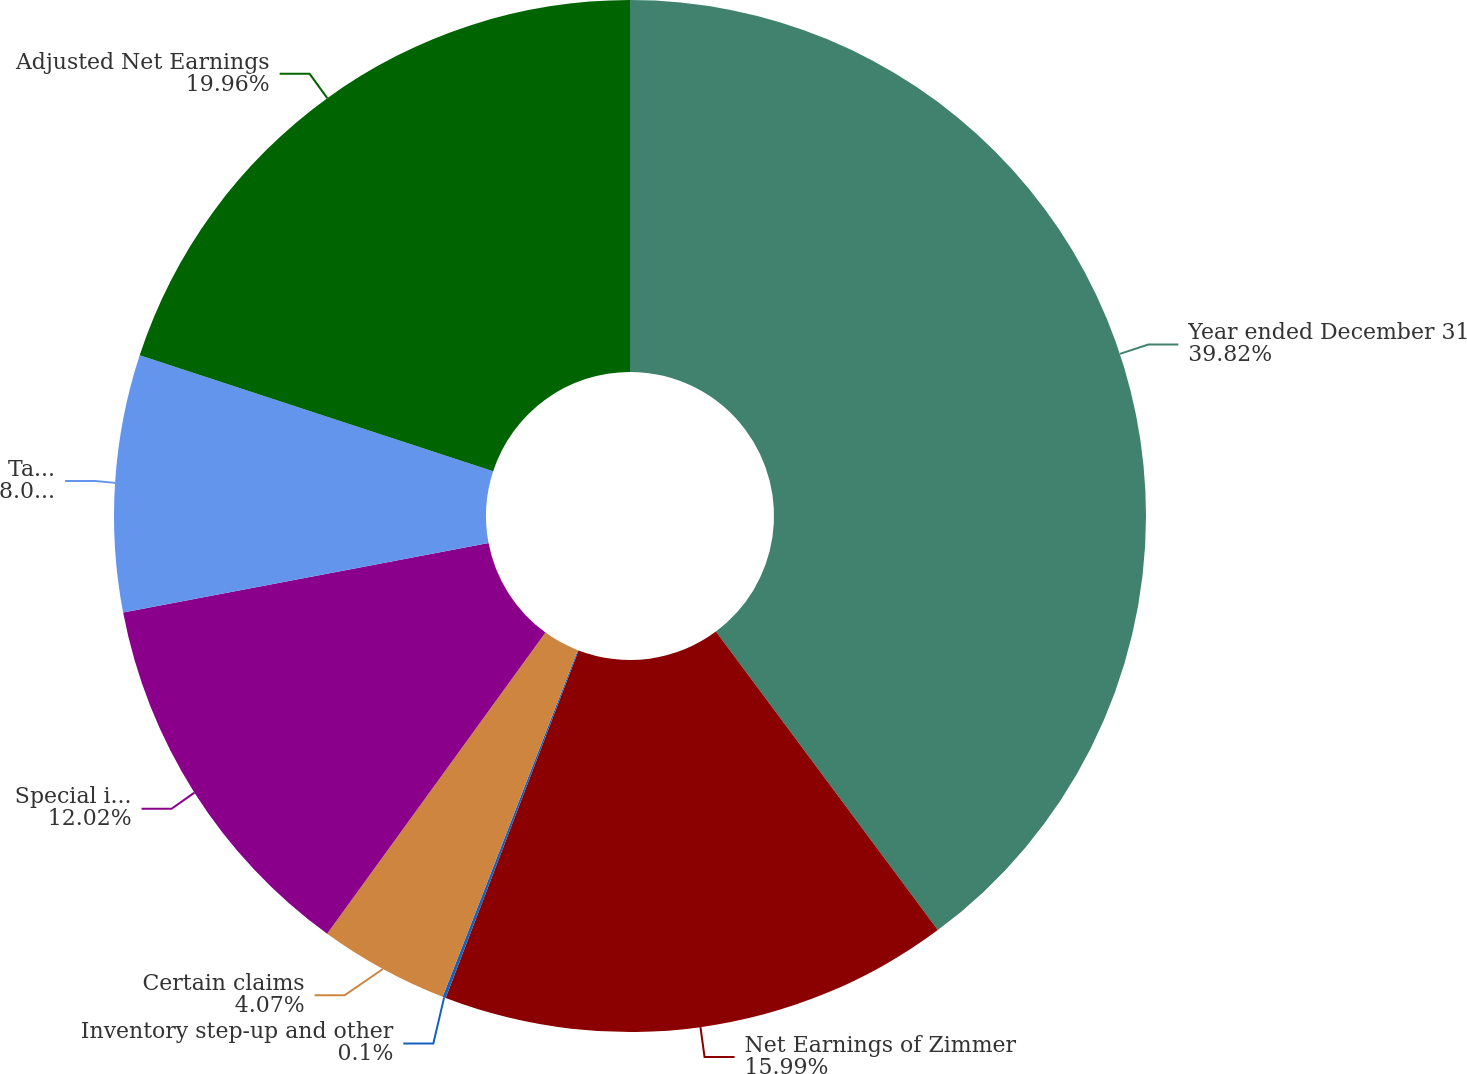Convert chart to OTSL. <chart><loc_0><loc_0><loc_500><loc_500><pie_chart><fcel>Year ended December 31<fcel>Net Earnings of Zimmer<fcel>Inventory step-up and other<fcel>Certain claims<fcel>Special items<fcel>Taxes on above items and other<fcel>Adjusted Net Earnings<nl><fcel>39.83%<fcel>15.99%<fcel>0.1%<fcel>4.07%<fcel>12.02%<fcel>8.04%<fcel>19.96%<nl></chart> 